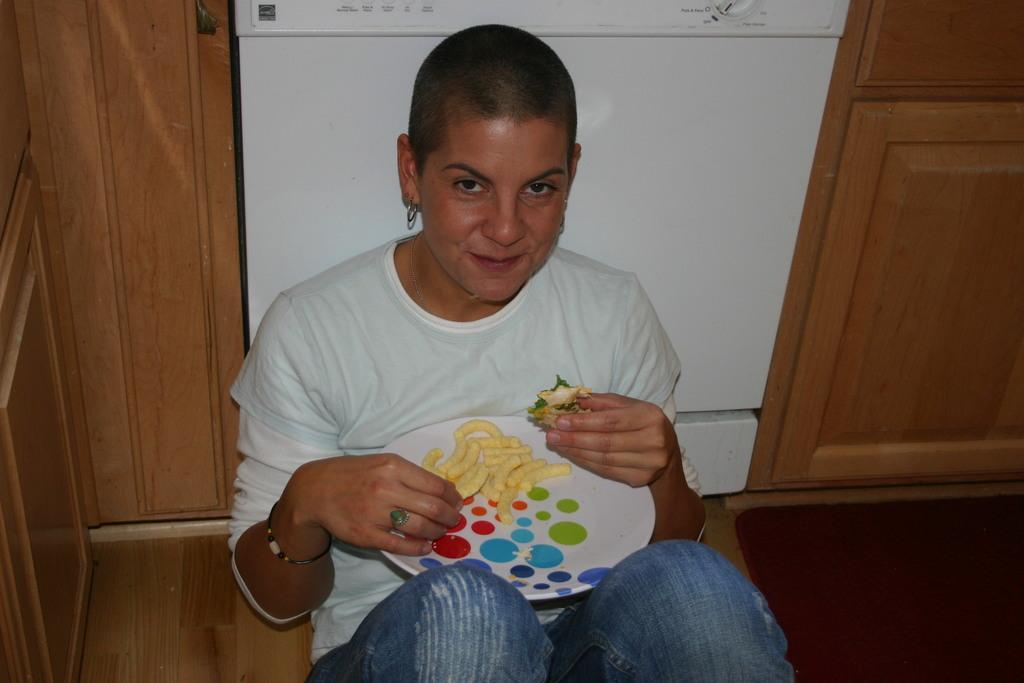How would you summarize this image in a sentence or two? In this image I can see a person wearing white and blue colored dress is sitting on the floor and holding a plate and food item in hands. In the background I can see a dishwasher and few wooden cupboards. 